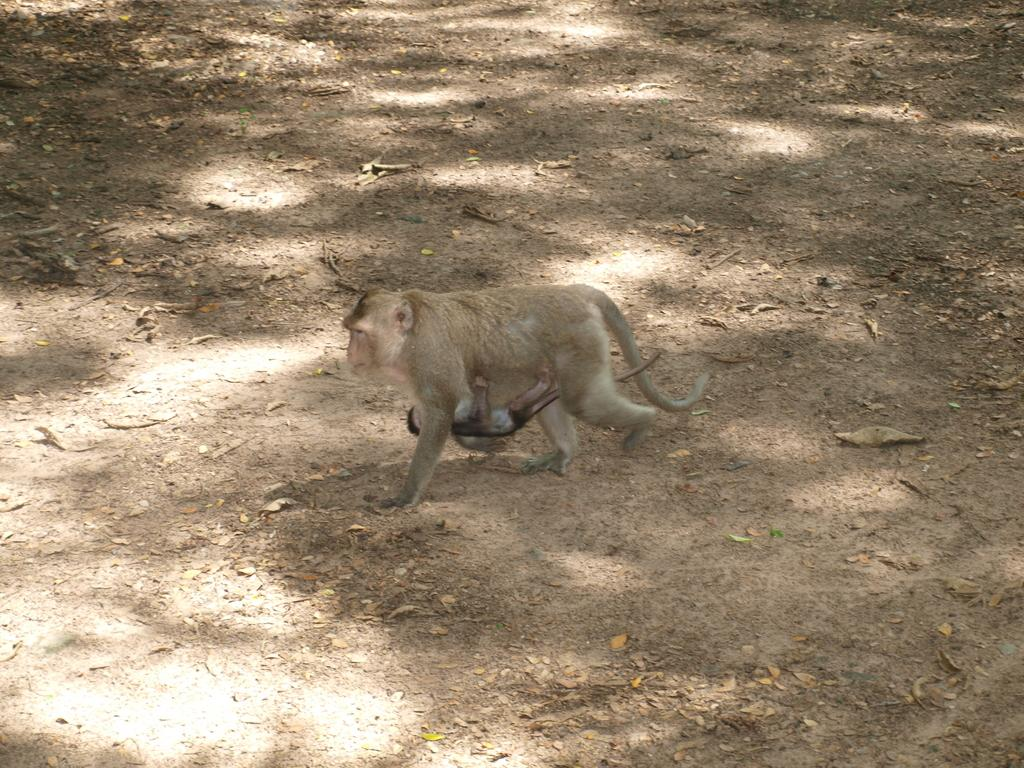What animal is the main subject of the image? There is a monkey in the image. What is the monkey doing in the image? The monkey is holding a baby monkey. What type of shoe is the monkey wearing in the image? There is no shoe present in the image, as the monkey is an animal and does not wear shoes. 